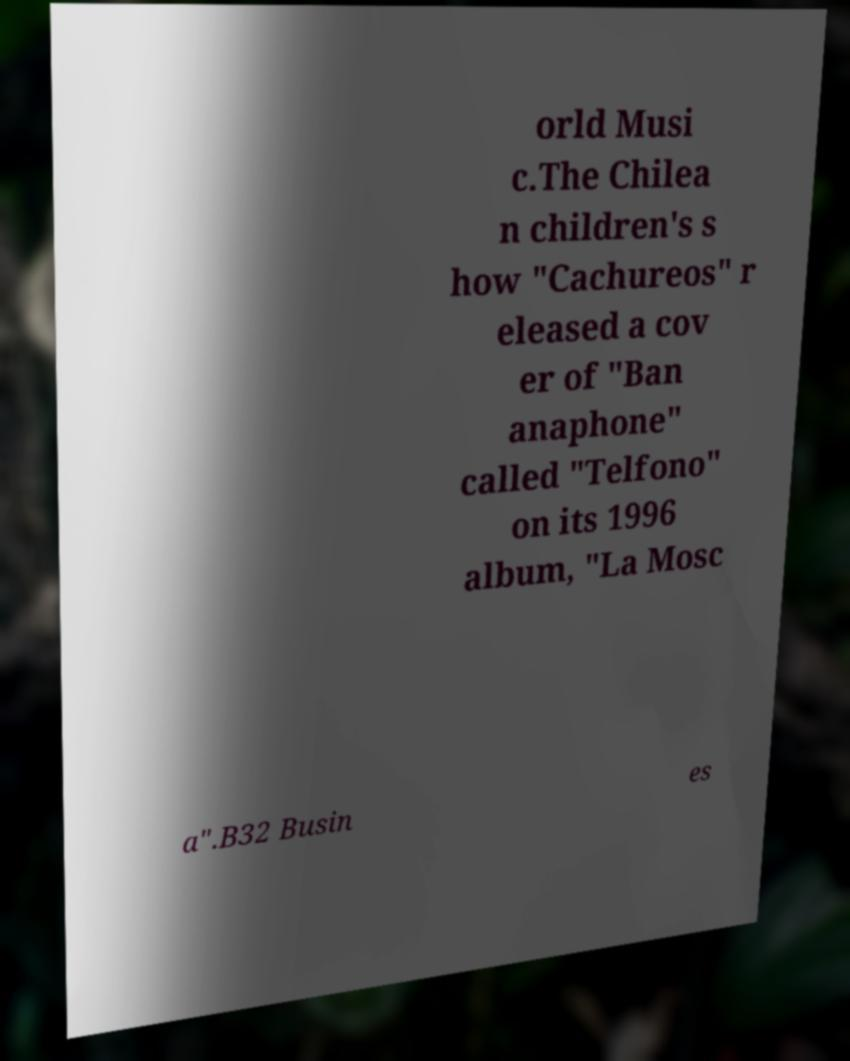Could you assist in decoding the text presented in this image and type it out clearly? orld Musi c.The Chilea n children's s how "Cachureos" r eleased a cov er of "Ban anaphone" called "Telfono" on its 1996 album, "La Mosc a".B32 Busin es 